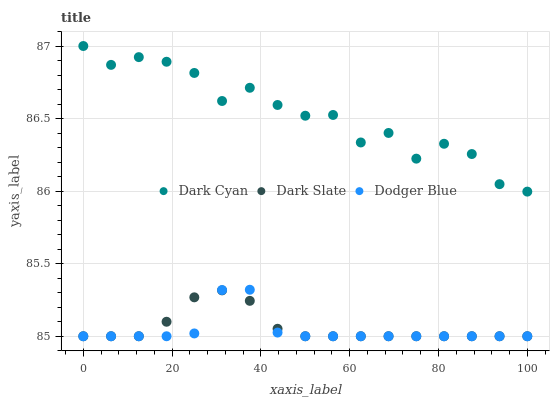Does Dodger Blue have the minimum area under the curve?
Answer yes or no. Yes. Does Dark Cyan have the maximum area under the curve?
Answer yes or no. Yes. Does Dark Slate have the minimum area under the curve?
Answer yes or no. No. Does Dark Slate have the maximum area under the curve?
Answer yes or no. No. Is Dark Slate the smoothest?
Answer yes or no. Yes. Is Dark Cyan the roughest?
Answer yes or no. Yes. Is Dodger Blue the smoothest?
Answer yes or no. No. Is Dodger Blue the roughest?
Answer yes or no. No. Does Dark Slate have the lowest value?
Answer yes or no. Yes. Does Dark Cyan have the highest value?
Answer yes or no. Yes. Does Dodger Blue have the highest value?
Answer yes or no. No. Is Dodger Blue less than Dark Cyan?
Answer yes or no. Yes. Is Dark Cyan greater than Dark Slate?
Answer yes or no. Yes. Does Dodger Blue intersect Dark Slate?
Answer yes or no. Yes. Is Dodger Blue less than Dark Slate?
Answer yes or no. No. Is Dodger Blue greater than Dark Slate?
Answer yes or no. No. Does Dodger Blue intersect Dark Cyan?
Answer yes or no. No. 